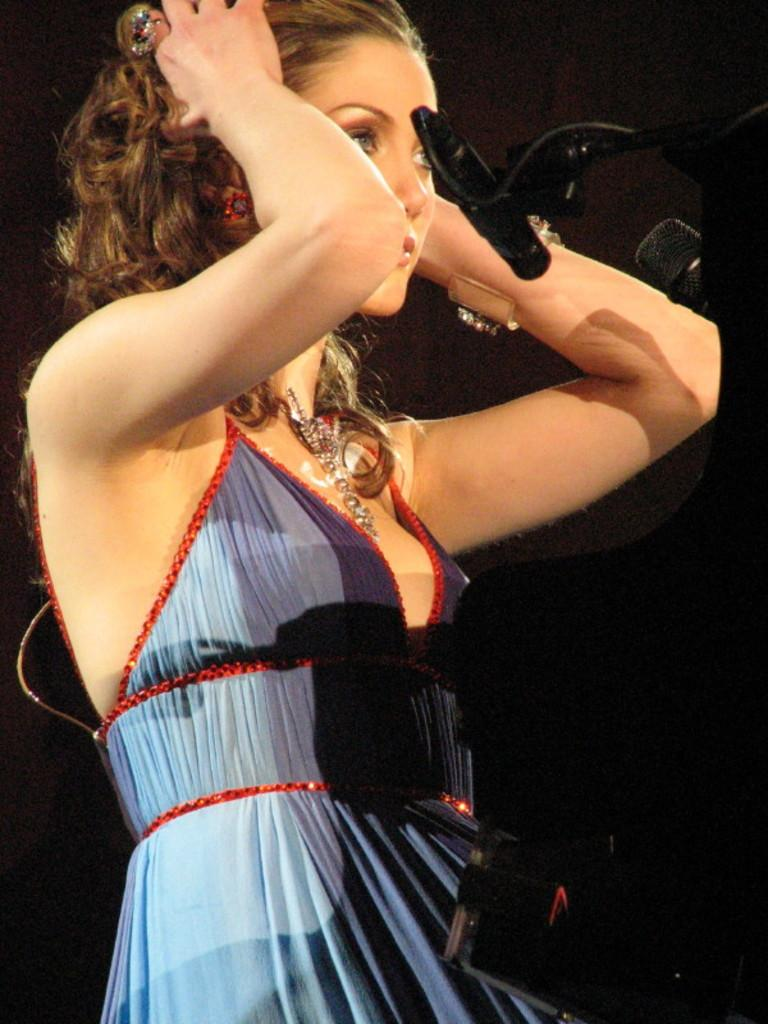Who is present in the image? There is a woman in the image. What objects can be seen on the right side of the image? There are microphones and a black object on the right side of the image. How would you describe the overall lighting in the image? The background of the image is dark. What type of protest is taking place in the image? There is no protest present in the image. Can you hear the woman's voice in the image? The image is a still photograph, so it does not capture sound or voices. 